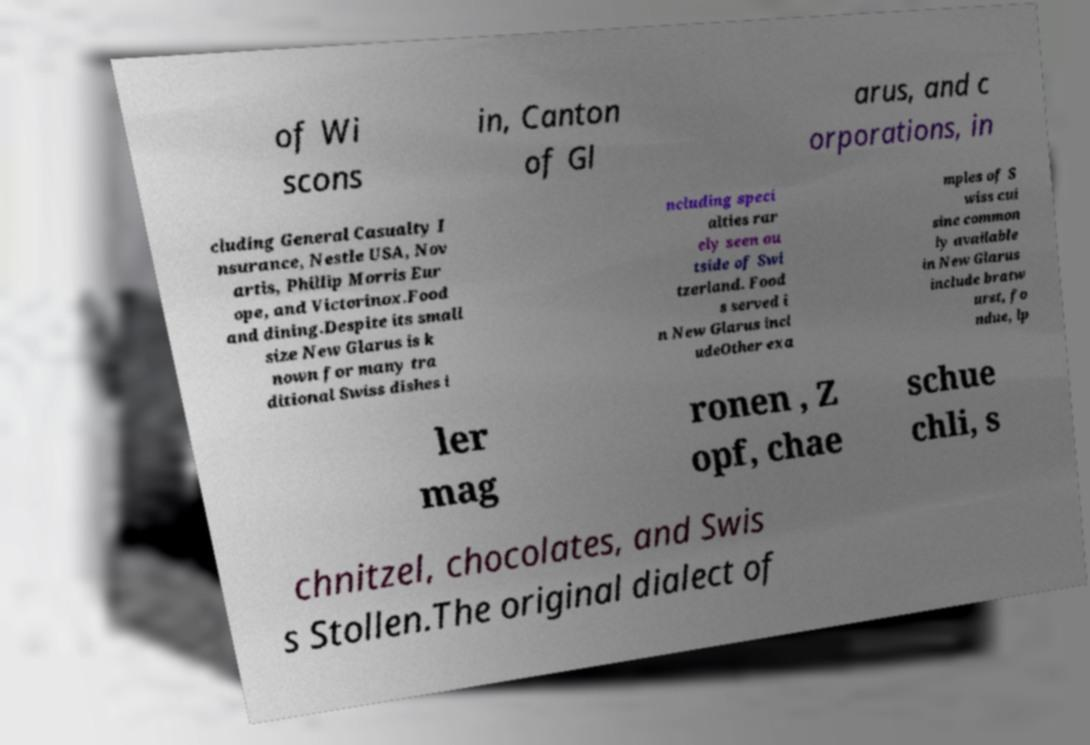Can you read and provide the text displayed in the image?This photo seems to have some interesting text. Can you extract and type it out for me? of Wi scons in, Canton of Gl arus, and c orporations, in cluding General Casualty I nsurance, Nestle USA, Nov artis, Phillip Morris Eur ope, and Victorinox.Food and dining.Despite its small size New Glarus is k nown for many tra ditional Swiss dishes i ncluding speci alties rar ely seen ou tside of Swi tzerland. Food s served i n New Glarus incl udeOther exa mples of S wiss cui sine common ly available in New Glarus include bratw urst, fo ndue, lp ler mag ronen , Z opf, chae schue chli, s chnitzel, chocolates, and Swis s Stollen.The original dialect of 